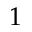<formula> <loc_0><loc_0><loc_500><loc_500>1</formula> 